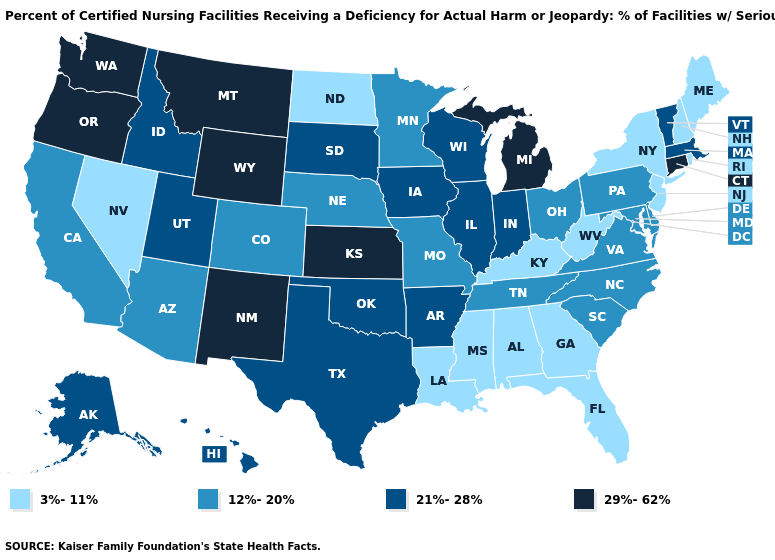Does the first symbol in the legend represent the smallest category?
Short answer required. Yes. What is the value of Rhode Island?
Keep it brief. 3%-11%. What is the highest value in states that border Wyoming?
Keep it brief. 29%-62%. Among the states that border New Mexico , does Arizona have the lowest value?
Write a very short answer. Yes. Among the states that border Wisconsin , which have the lowest value?
Keep it brief. Minnesota. What is the value of New Hampshire?
Concise answer only. 3%-11%. What is the lowest value in the Northeast?
Be succinct. 3%-11%. Is the legend a continuous bar?
Answer briefly. No. Among the states that border Tennessee , which have the lowest value?
Short answer required. Alabama, Georgia, Kentucky, Mississippi. What is the value of New Mexico?
Quick response, please. 29%-62%. Name the states that have a value in the range 21%-28%?
Answer briefly. Alaska, Arkansas, Hawaii, Idaho, Illinois, Indiana, Iowa, Massachusetts, Oklahoma, South Dakota, Texas, Utah, Vermont, Wisconsin. What is the value of South Dakota?
Give a very brief answer. 21%-28%. What is the value of Washington?
Keep it brief. 29%-62%. Name the states that have a value in the range 21%-28%?
Give a very brief answer. Alaska, Arkansas, Hawaii, Idaho, Illinois, Indiana, Iowa, Massachusetts, Oklahoma, South Dakota, Texas, Utah, Vermont, Wisconsin. Does Montana have a lower value than New Jersey?
Give a very brief answer. No. 